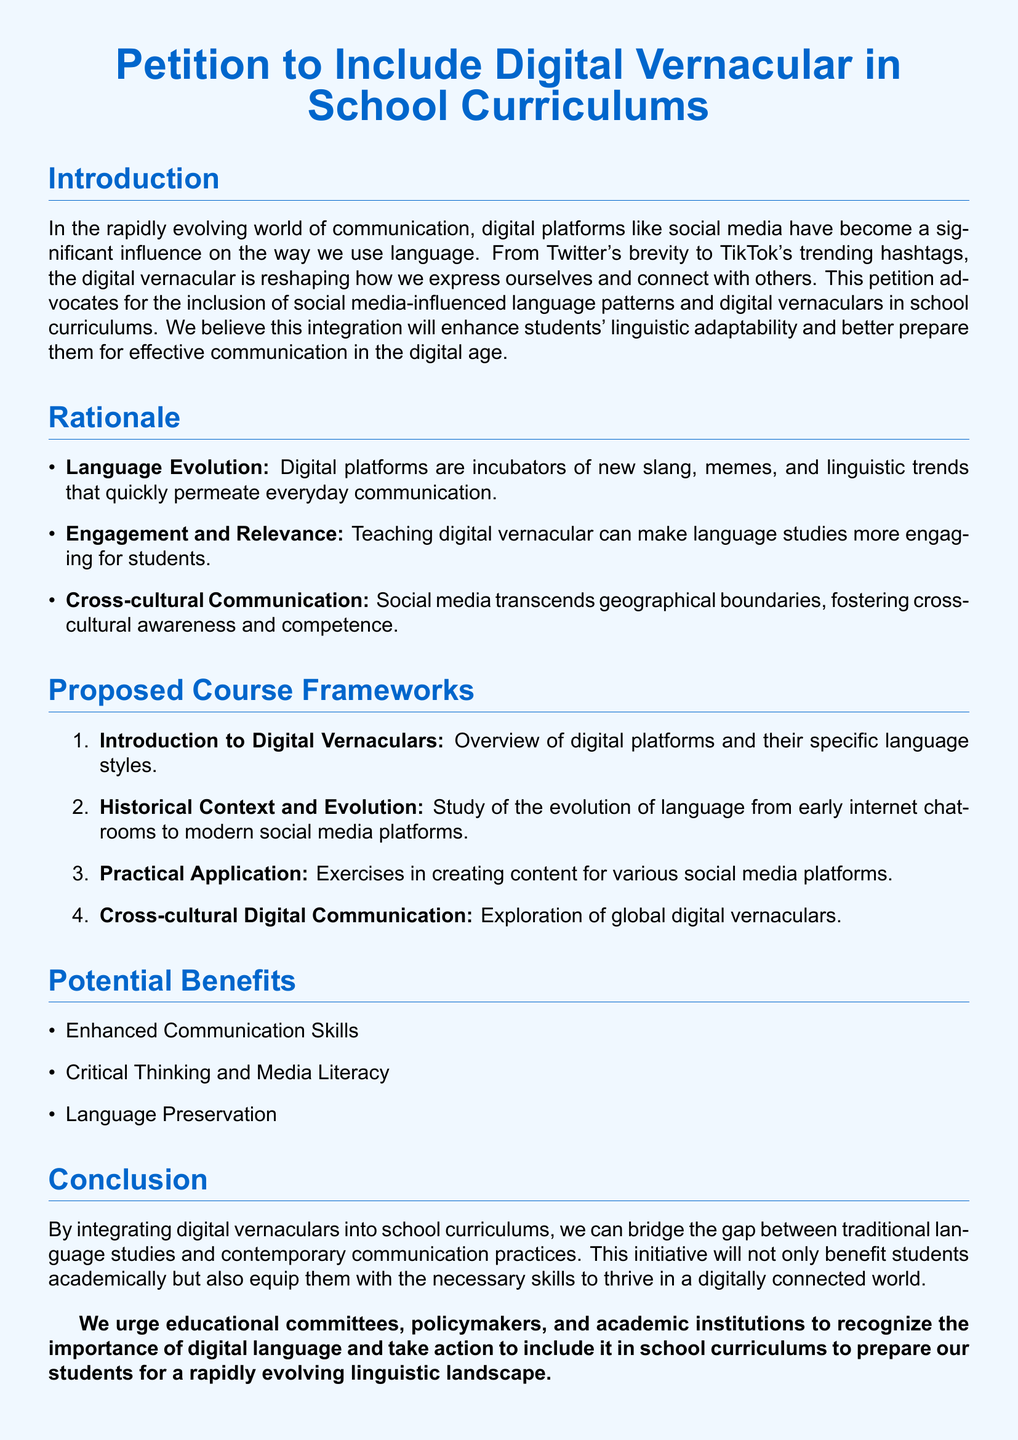What is the title of the petition? The title is specifically stated at the beginning of the document, which is "Petition to Include Digital Vernacular in School Curriculums."
Answer: Petition to Include Digital Vernacular in School Curriculums What is one benefit of including digital vernacular in curriculums? The potential benefits outlined in the document specifically include enhanced communication skills, among others.
Answer: Enhanced Communication Skills How many proposed course frameworks are listed? The number of proposed course frameworks can be found in the relevant section, which enumerates four distinct frameworks.
Answer: 4 What is the first proposed course framework? The first proposed course framework is outlined directly in the list provided, which starts with an overview of digital platforms.
Answer: Introduction to Digital Vernaculars What type of influence does social media have on language? The document explicitly states that social media has a significant influence on how we use language.
Answer: Significant influence What is one reason for teaching digital vernacular? The rationale includes engagement and relevance as key reasons for teaching digital vernaculars.
Answer: Engagement and Relevance What is the name of the section where potential benefits are listed? The potential benefits are listed under a clearly defined section titled "Potential Benefits."
Answer: Potential Benefits Who is the call to action directed towards? The call to action in the conclusion is directed towards educational committees, policymakers, and academic institutions.
Answer: Educational committees, policymakers, and academic institutions 